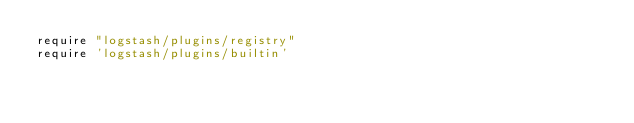<code> <loc_0><loc_0><loc_500><loc_500><_Ruby_>require "logstash/plugins/registry"
require 'logstash/plugins/builtin'</code> 